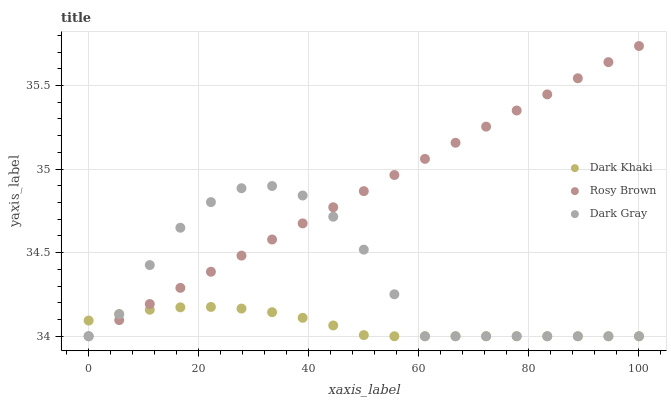Does Dark Khaki have the minimum area under the curve?
Answer yes or no. Yes. Does Rosy Brown have the maximum area under the curve?
Answer yes or no. Yes. Does Dark Gray have the minimum area under the curve?
Answer yes or no. No. Does Dark Gray have the maximum area under the curve?
Answer yes or no. No. Is Rosy Brown the smoothest?
Answer yes or no. Yes. Is Dark Gray the roughest?
Answer yes or no. Yes. Is Dark Gray the smoothest?
Answer yes or no. No. Is Rosy Brown the roughest?
Answer yes or no. No. Does Dark Khaki have the lowest value?
Answer yes or no. Yes. Does Rosy Brown have the highest value?
Answer yes or no. Yes. Does Dark Gray have the highest value?
Answer yes or no. No. Does Rosy Brown intersect Dark Gray?
Answer yes or no. Yes. Is Rosy Brown less than Dark Gray?
Answer yes or no. No. Is Rosy Brown greater than Dark Gray?
Answer yes or no. No. 